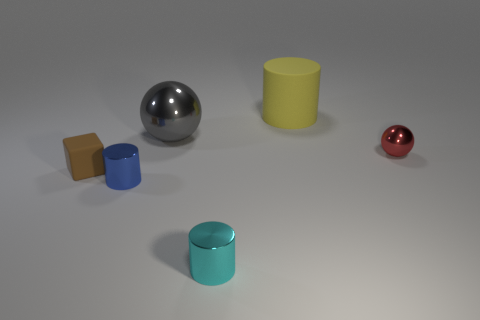Add 2 large brown cubes. How many objects exist? 8 Subtract all cubes. How many objects are left? 5 Subtract 0 red cylinders. How many objects are left? 6 Subtract all matte blocks. Subtract all large brown rubber cylinders. How many objects are left? 5 Add 3 tiny blue metal cylinders. How many tiny blue metal cylinders are left? 4 Add 2 red metallic objects. How many red metallic objects exist? 3 